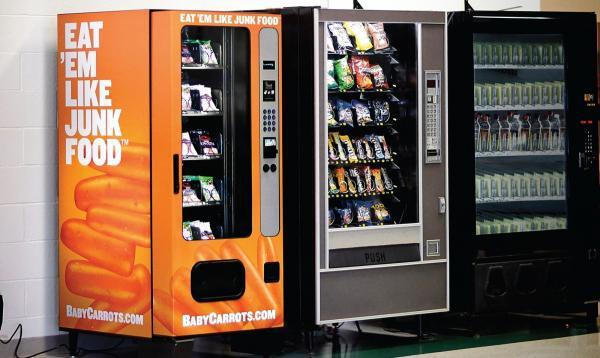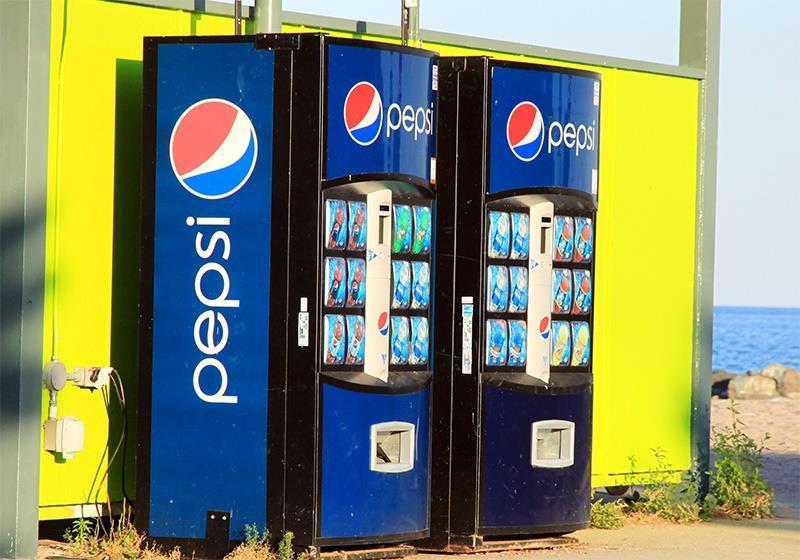The first image is the image on the left, the second image is the image on the right. For the images shown, is this caption "All images only show beverages." true? Answer yes or no. No. 